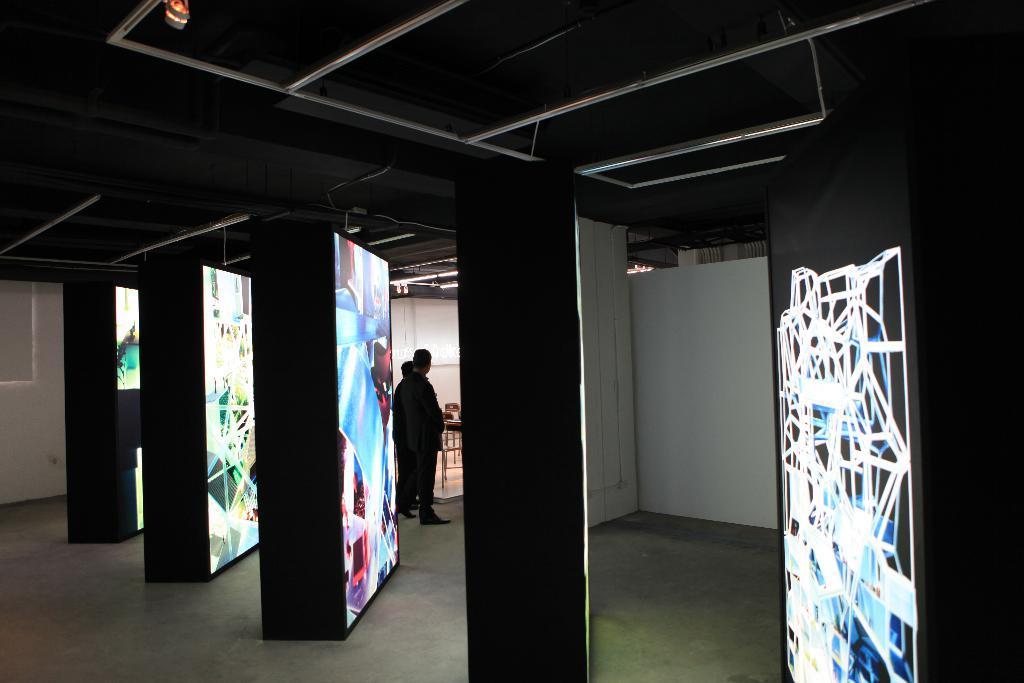How would you summarize this image in a sentence or two? In the center of the image we can see rectangle shape objects with screens. In the background there is a wall, board, wooden object, stools, lights, few people are standing and a few other objects. 